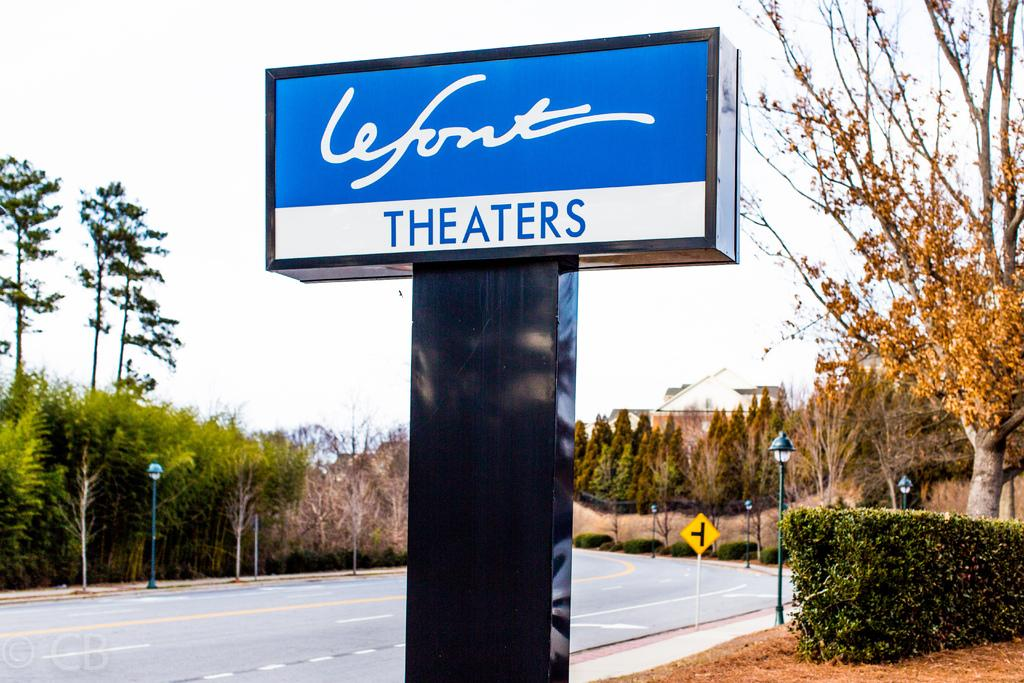What is the main feature of the image? There is a road in the image. What else can be seen along the road? There are poles, lights, boards, plants, and trees in the image. What is visible in the background of the image? The sky is visible in the background of the image. What type of pen is being used to draw on the boards in the image? There is no pen or drawing activity present in the image; the boards are likely used for signage or advertisements. 